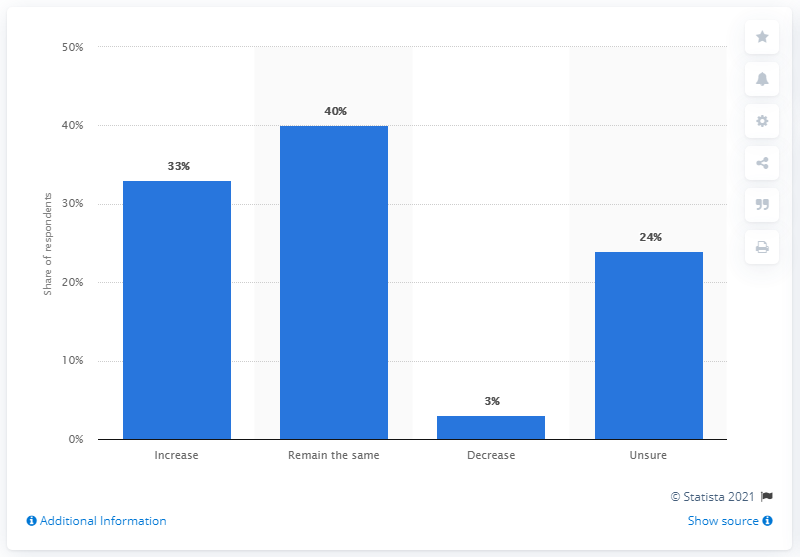Give some essential details in this illustration. Thirty percent of respondents revealed that they are planning to decrease their content marketing spending in the upcoming 12 months. 